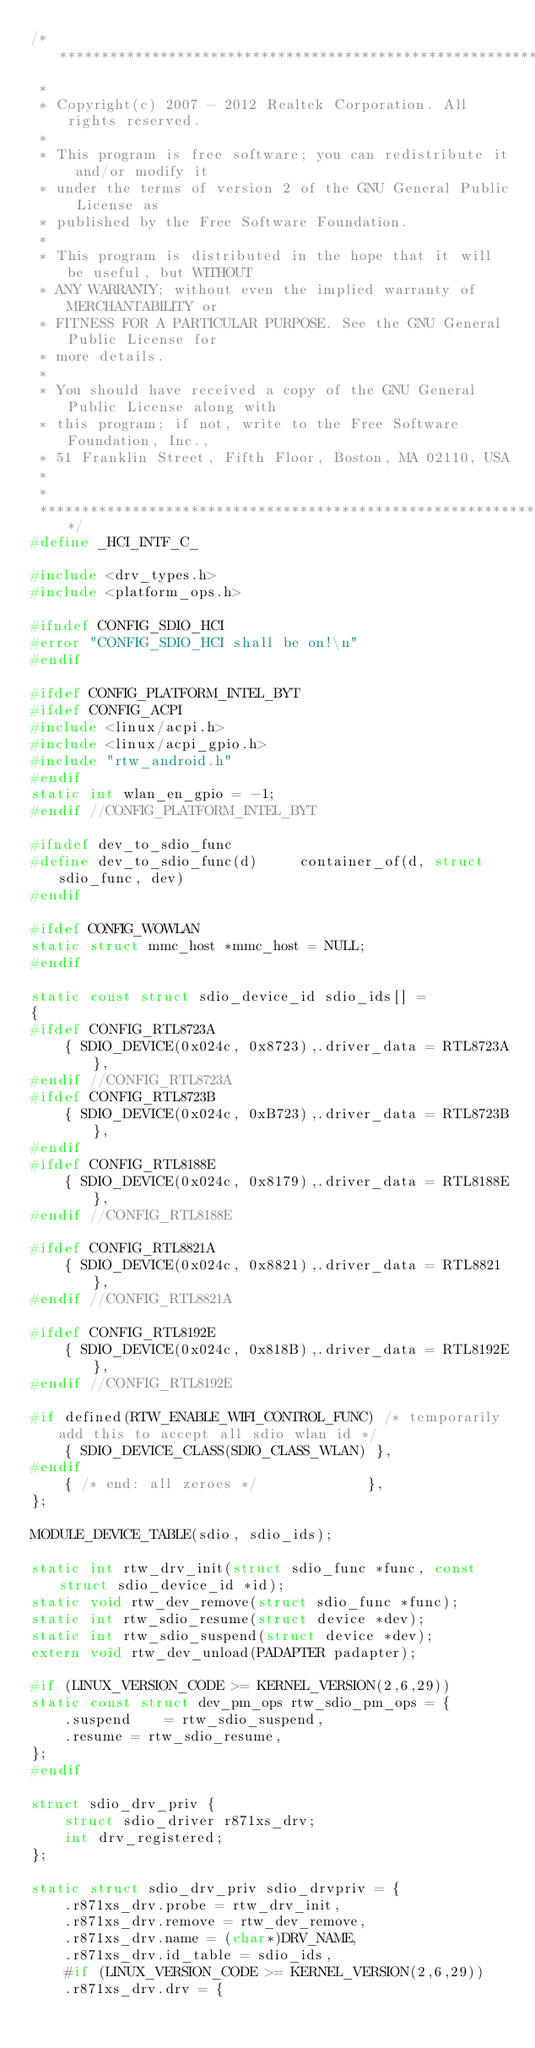<code> <loc_0><loc_0><loc_500><loc_500><_C_>/******************************************************************************
 *
 * Copyright(c) 2007 - 2012 Realtek Corporation. All rights reserved.
 *
 * This program is free software; you can redistribute it and/or modify it
 * under the terms of version 2 of the GNU General Public License as
 * published by the Free Software Foundation.
 *
 * This program is distributed in the hope that it will be useful, but WITHOUT
 * ANY WARRANTY; without even the implied warranty of MERCHANTABILITY or
 * FITNESS FOR A PARTICULAR PURPOSE. See the GNU General Public License for
 * more details.
 *
 * You should have received a copy of the GNU General Public License along with
 * this program; if not, write to the Free Software Foundation, Inc.,
 * 51 Franklin Street, Fifth Floor, Boston, MA 02110, USA
 *
 *
 ******************************************************************************/
#define _HCI_INTF_C_

#include <drv_types.h>
#include <platform_ops.h>

#ifndef CONFIG_SDIO_HCI
#error "CONFIG_SDIO_HCI shall be on!\n"
#endif

#ifdef CONFIG_PLATFORM_INTEL_BYT
#ifdef CONFIG_ACPI
#include <linux/acpi.h>
#include <linux/acpi_gpio.h>
#include "rtw_android.h"
#endif
static int wlan_en_gpio = -1;
#endif //CONFIG_PLATFORM_INTEL_BYT

#ifndef dev_to_sdio_func
#define dev_to_sdio_func(d)     container_of(d, struct sdio_func, dev)
#endif

#ifdef CONFIG_WOWLAN
static struct mmc_host *mmc_host = NULL;
#endif

static const struct sdio_device_id sdio_ids[] =
{
#ifdef CONFIG_RTL8723A
	{ SDIO_DEVICE(0x024c, 0x8723),.driver_data = RTL8723A},
#endif //CONFIG_RTL8723A
#ifdef CONFIG_RTL8723B
	{ SDIO_DEVICE(0x024c, 0xB723),.driver_data = RTL8723B},
#endif
#ifdef CONFIG_RTL8188E
	{ SDIO_DEVICE(0x024c, 0x8179),.driver_data = RTL8188E},
#endif //CONFIG_RTL8188E

#ifdef CONFIG_RTL8821A
	{ SDIO_DEVICE(0x024c, 0x8821),.driver_data = RTL8821},
#endif //CONFIG_RTL8821A

#ifdef CONFIG_RTL8192E
	{ SDIO_DEVICE(0x024c, 0x818B),.driver_data = RTL8192E},
#endif //CONFIG_RTL8192E

#if defined(RTW_ENABLE_WIFI_CONTROL_FUNC) /* temporarily add this to accept all sdio wlan id */
	{ SDIO_DEVICE_CLASS(SDIO_CLASS_WLAN) },
#endif
	{ /* end: all zeroes */				},
};

MODULE_DEVICE_TABLE(sdio, sdio_ids);

static int rtw_drv_init(struct sdio_func *func, const struct sdio_device_id *id);
static void rtw_dev_remove(struct sdio_func *func);
static int rtw_sdio_resume(struct device *dev);
static int rtw_sdio_suspend(struct device *dev);
extern void rtw_dev_unload(PADAPTER padapter);

#if (LINUX_VERSION_CODE >= KERNEL_VERSION(2,6,29)) 
static const struct dev_pm_ops rtw_sdio_pm_ops = {
	.suspend	= rtw_sdio_suspend,
	.resume	= rtw_sdio_resume,
};
#endif
	
struct sdio_drv_priv {
	struct sdio_driver r871xs_drv;
	int drv_registered;
};

static struct sdio_drv_priv sdio_drvpriv = {
	.r871xs_drv.probe = rtw_drv_init,
	.r871xs_drv.remove = rtw_dev_remove,
	.r871xs_drv.name = (char*)DRV_NAME,
	.r871xs_drv.id_table = sdio_ids,
	#if (LINUX_VERSION_CODE >= KERNEL_VERSION(2,6,29)) 
	.r871xs_drv.drv = {</code> 